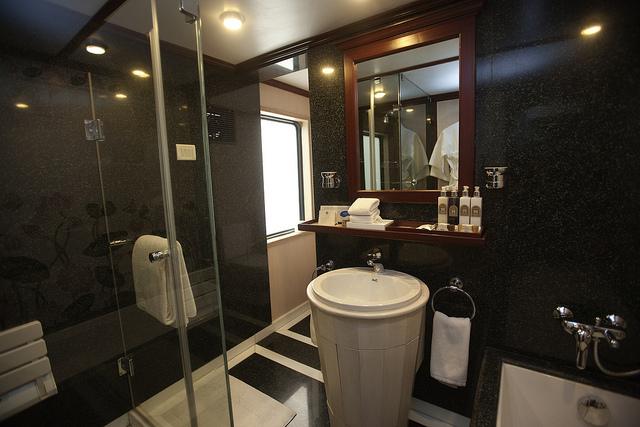Are the walls dark?
Short answer required. Yes. Can you see through the shower door?
Concise answer only. Yes. What room are they in?
Quick response, please. Bathroom. 